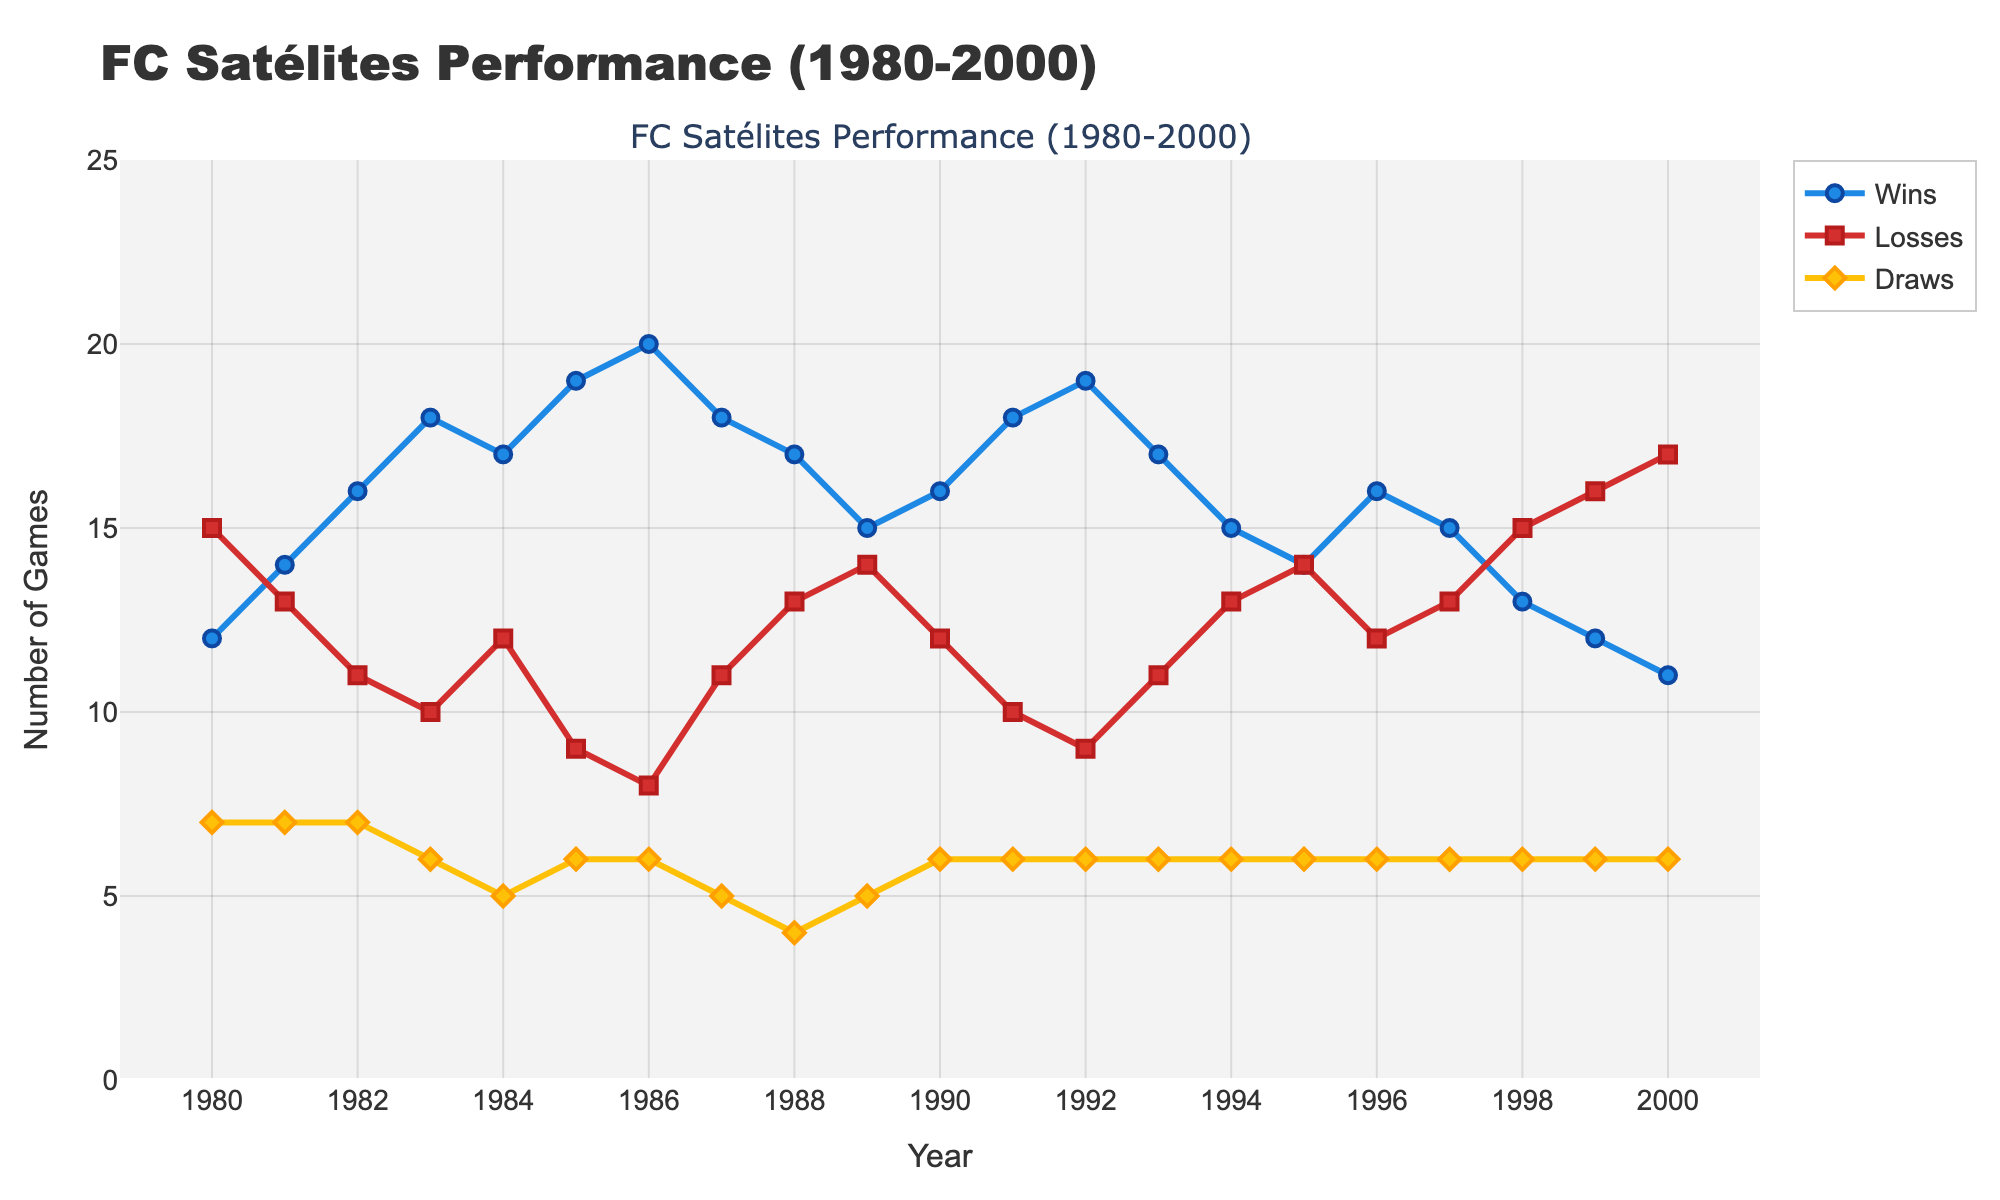What year did FC Satélites have the highest number of wins? To determine the year with the highest number of wins, look at the peak point of the 'Wins' line, which occurs in 1986.
Answer: 1986 In which year did FC Satélites have the most losses? Look at the 'Losses' line and find the peak value, which occurs in 2000.
Answer: 2000 Compare the number of wins and losses in 1992. Did they win more games than they lost? In 1992, the figure shows 19 wins and 9 losses. Compare these two values to find that wins are greater than losses.
Answer: Yes What is the difference between the number of wins and losses in 1985? In 1985, wins are 19 and losses are 9. The difference is calculated as 19 - 9.
Answer: 10 Did the number of draws remain stable over the years? Evaluate the 'Draws' line to see if it fluctuates significantly. The 'Draws' line mostly stays within a small range of 4-7, indicating stability.
Answer: Yes How many total games (wins + losses + draws) did FC Satélites play in 1983? Sum the values for wins, losses, and draws in 1983: 18 wins + 10 losses + 6 draws.
Answer: 34 In which year was the difference between wins and losses the smallest? Calculate the difference between wins and losses for each year and find the smallest difference. In 1995, the difference is 14 - 14 = 0.
Answer: 1995 By how much did the number of wins decline from 1986 to 2000? Compare the number of wins in 1986 (20) and 2000 (11). The difference is 20 - 11.
Answer: 9 Identify a period of consistent growth in the number of wins. When did it occur? Look for a consecutive period where the 'Wins' line increases consistently. From 1981 to 1986, there is a year-on-year growth in wins.
Answer: 1981-1986 Were there any years when the number of wins, losses, and draws were exactly the same? Inspect the lines to see if there is any year when the wins, losses, and draws intersect. There are no years where the three lines converge.
Answer: No 